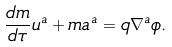<formula> <loc_0><loc_0><loc_500><loc_500>\frac { d m } { d \tau } u ^ { a } + m a ^ { a } = q \nabla ^ { a } \phi .</formula> 